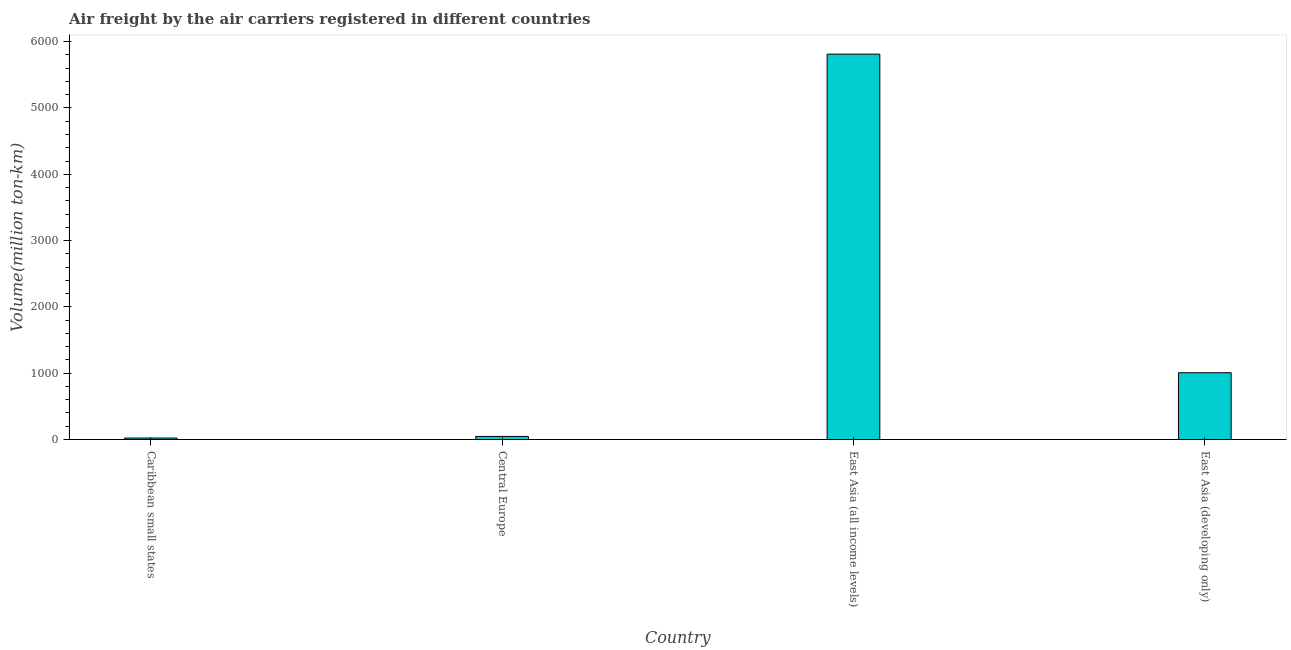Does the graph contain any zero values?
Provide a succinct answer. No. Does the graph contain grids?
Keep it short and to the point. No. What is the title of the graph?
Ensure brevity in your answer.  Air freight by the air carriers registered in different countries. What is the label or title of the X-axis?
Your answer should be compact. Country. What is the label or title of the Y-axis?
Make the answer very short. Volume(million ton-km). What is the air freight in East Asia (developing only)?
Your answer should be compact. 1007.4. Across all countries, what is the maximum air freight?
Keep it short and to the point. 5812.1. Across all countries, what is the minimum air freight?
Keep it short and to the point. 22.1. In which country was the air freight maximum?
Make the answer very short. East Asia (all income levels). In which country was the air freight minimum?
Keep it short and to the point. Caribbean small states. What is the sum of the air freight?
Offer a terse response. 6888.1. What is the difference between the air freight in Caribbean small states and Central Europe?
Offer a very short reply. -24.4. What is the average air freight per country?
Your response must be concise. 1722.03. What is the median air freight?
Make the answer very short. 526.95. In how many countries, is the air freight greater than 200 million ton-km?
Keep it short and to the point. 2. What is the ratio of the air freight in Central Europe to that in East Asia (all income levels)?
Provide a short and direct response. 0.01. Is the air freight in Central Europe less than that in East Asia (all income levels)?
Make the answer very short. Yes. What is the difference between the highest and the second highest air freight?
Your response must be concise. 4804.7. Is the sum of the air freight in Caribbean small states and East Asia (all income levels) greater than the maximum air freight across all countries?
Your response must be concise. Yes. What is the difference between the highest and the lowest air freight?
Provide a short and direct response. 5790. How many bars are there?
Ensure brevity in your answer.  4. Are all the bars in the graph horizontal?
Offer a very short reply. No. What is the Volume(million ton-km) in Caribbean small states?
Keep it short and to the point. 22.1. What is the Volume(million ton-km) in Central Europe?
Your response must be concise. 46.5. What is the Volume(million ton-km) of East Asia (all income levels)?
Ensure brevity in your answer.  5812.1. What is the Volume(million ton-km) in East Asia (developing only)?
Offer a very short reply. 1007.4. What is the difference between the Volume(million ton-km) in Caribbean small states and Central Europe?
Your response must be concise. -24.4. What is the difference between the Volume(million ton-km) in Caribbean small states and East Asia (all income levels)?
Provide a succinct answer. -5790. What is the difference between the Volume(million ton-km) in Caribbean small states and East Asia (developing only)?
Your answer should be very brief. -985.3. What is the difference between the Volume(million ton-km) in Central Europe and East Asia (all income levels)?
Offer a terse response. -5765.6. What is the difference between the Volume(million ton-km) in Central Europe and East Asia (developing only)?
Ensure brevity in your answer.  -960.9. What is the difference between the Volume(million ton-km) in East Asia (all income levels) and East Asia (developing only)?
Your answer should be very brief. 4804.7. What is the ratio of the Volume(million ton-km) in Caribbean small states to that in Central Europe?
Give a very brief answer. 0.47. What is the ratio of the Volume(million ton-km) in Caribbean small states to that in East Asia (all income levels)?
Provide a short and direct response. 0. What is the ratio of the Volume(million ton-km) in Caribbean small states to that in East Asia (developing only)?
Your response must be concise. 0.02. What is the ratio of the Volume(million ton-km) in Central Europe to that in East Asia (all income levels)?
Ensure brevity in your answer.  0.01. What is the ratio of the Volume(million ton-km) in Central Europe to that in East Asia (developing only)?
Provide a succinct answer. 0.05. What is the ratio of the Volume(million ton-km) in East Asia (all income levels) to that in East Asia (developing only)?
Ensure brevity in your answer.  5.77. 